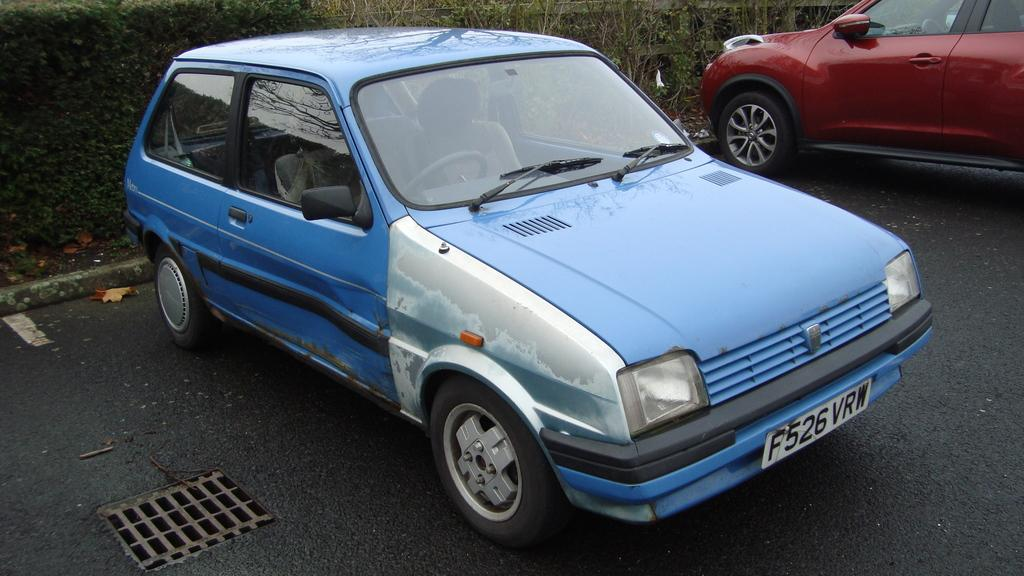What color is the car in the image? The car in the image is red and blue. Where is the car located in the image? The car is on the road in the image. What can be seen in the background of the image? There are plants and grass in the background of the image. How many tickets are visible in the image? There are no tickets present in the image. What type of seed can be seen growing in the background of the image? There is no seed visible in the image; only plants and grass are present in the background. 